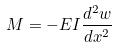Convert formula to latex. <formula><loc_0><loc_0><loc_500><loc_500>M = - E I \frac { d ^ { 2 } w } { d x ^ { 2 } }</formula> 